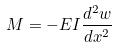Convert formula to latex. <formula><loc_0><loc_0><loc_500><loc_500>M = - E I \frac { d ^ { 2 } w } { d x ^ { 2 } }</formula> 